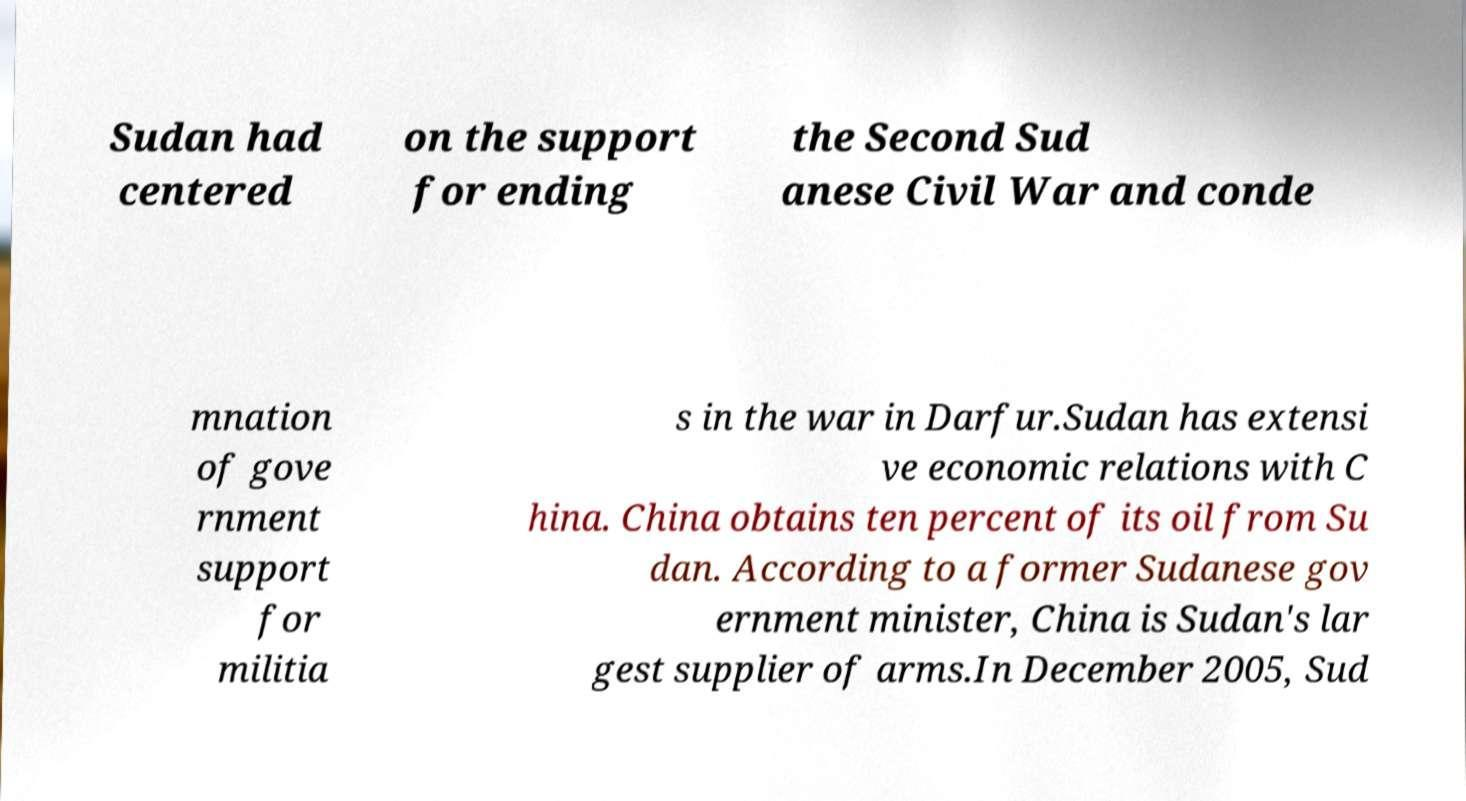Could you extract and type out the text from this image? Sudan had centered on the support for ending the Second Sud anese Civil War and conde mnation of gove rnment support for militia s in the war in Darfur.Sudan has extensi ve economic relations with C hina. China obtains ten percent of its oil from Su dan. According to a former Sudanese gov ernment minister, China is Sudan's lar gest supplier of arms.In December 2005, Sud 